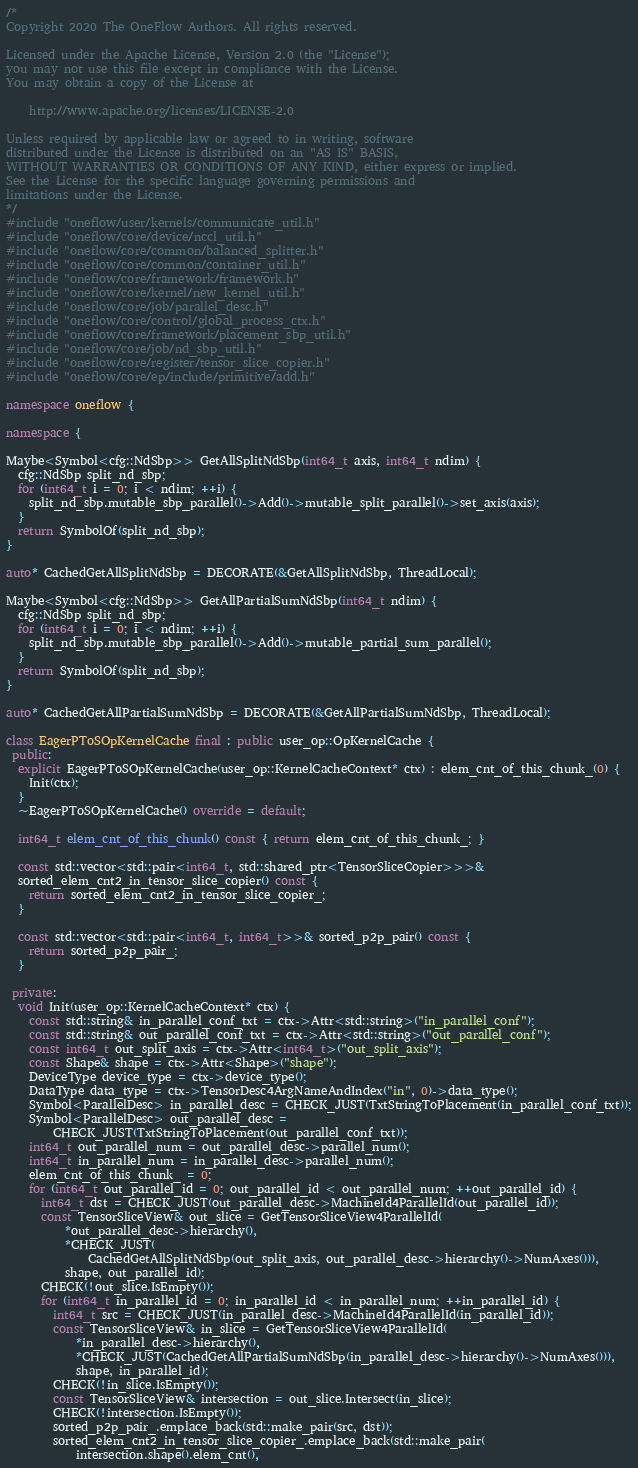<code> <loc_0><loc_0><loc_500><loc_500><_C++_>/*
Copyright 2020 The OneFlow Authors. All rights reserved.

Licensed under the Apache License, Version 2.0 (the "License");
you may not use this file except in compliance with the License.
You may obtain a copy of the License at

    http://www.apache.org/licenses/LICENSE-2.0

Unless required by applicable law or agreed to in writing, software
distributed under the License is distributed on an "AS IS" BASIS,
WITHOUT WARRANTIES OR CONDITIONS OF ANY KIND, either express or implied.
See the License for the specific language governing permissions and
limitations under the License.
*/
#include "oneflow/user/kernels/communicate_util.h"
#include "oneflow/core/device/nccl_util.h"
#include "oneflow/core/common/balanced_splitter.h"
#include "oneflow/core/common/container_util.h"
#include "oneflow/core/framework/framework.h"
#include "oneflow/core/kernel/new_kernel_util.h"
#include "oneflow/core/job/parallel_desc.h"
#include "oneflow/core/control/global_process_ctx.h"
#include "oneflow/core/framework/placement_sbp_util.h"
#include "oneflow/core/job/nd_sbp_util.h"
#include "oneflow/core/register/tensor_slice_copier.h"
#include "oneflow/core/ep/include/primitive/add.h"

namespace oneflow {

namespace {

Maybe<Symbol<cfg::NdSbp>> GetAllSplitNdSbp(int64_t axis, int64_t ndim) {
  cfg::NdSbp split_nd_sbp;
  for (int64_t i = 0; i < ndim; ++i) {
    split_nd_sbp.mutable_sbp_parallel()->Add()->mutable_split_parallel()->set_axis(axis);
  }
  return SymbolOf(split_nd_sbp);
}

auto* CachedGetAllSplitNdSbp = DECORATE(&GetAllSplitNdSbp, ThreadLocal);

Maybe<Symbol<cfg::NdSbp>> GetAllPartialSumNdSbp(int64_t ndim) {
  cfg::NdSbp split_nd_sbp;
  for (int64_t i = 0; i < ndim; ++i) {
    split_nd_sbp.mutable_sbp_parallel()->Add()->mutable_partial_sum_parallel();
  }
  return SymbolOf(split_nd_sbp);
}

auto* CachedGetAllPartialSumNdSbp = DECORATE(&GetAllPartialSumNdSbp, ThreadLocal);

class EagerPToSOpKernelCache final : public user_op::OpKernelCache {
 public:
  explicit EagerPToSOpKernelCache(user_op::KernelCacheContext* ctx) : elem_cnt_of_this_chunk_(0) {
    Init(ctx);
  }
  ~EagerPToSOpKernelCache() override = default;

  int64_t elem_cnt_of_this_chunk() const { return elem_cnt_of_this_chunk_; }

  const std::vector<std::pair<int64_t, std::shared_ptr<TensorSliceCopier>>>&
  sorted_elem_cnt2_in_tensor_slice_copier() const {
    return sorted_elem_cnt2_in_tensor_slice_copier_;
  }

  const std::vector<std::pair<int64_t, int64_t>>& sorted_p2p_pair() const {
    return sorted_p2p_pair_;
  }

 private:
  void Init(user_op::KernelCacheContext* ctx) {
    const std::string& in_parallel_conf_txt = ctx->Attr<std::string>("in_parallel_conf");
    const std::string& out_parallel_conf_txt = ctx->Attr<std::string>("out_parallel_conf");
    const int64_t out_split_axis = ctx->Attr<int64_t>("out_split_axis");
    const Shape& shape = ctx->Attr<Shape>("shape");
    DeviceType device_type = ctx->device_type();
    DataType data_type = ctx->TensorDesc4ArgNameAndIndex("in", 0)->data_type();
    Symbol<ParallelDesc> in_parallel_desc = CHECK_JUST(TxtStringToPlacement(in_parallel_conf_txt));
    Symbol<ParallelDesc> out_parallel_desc =
        CHECK_JUST(TxtStringToPlacement(out_parallel_conf_txt));
    int64_t out_parallel_num = out_parallel_desc->parallel_num();
    int64_t in_parallel_num = in_parallel_desc->parallel_num();
    elem_cnt_of_this_chunk_ = 0;
    for (int64_t out_parallel_id = 0; out_parallel_id < out_parallel_num; ++out_parallel_id) {
      int64_t dst = CHECK_JUST(out_parallel_desc->MachineId4ParallelId(out_parallel_id));
      const TensorSliceView& out_slice = GetTensorSliceView4ParallelId(
          *out_parallel_desc->hierarchy(),
          *CHECK_JUST(
              CachedGetAllSplitNdSbp(out_split_axis, out_parallel_desc->hierarchy()->NumAxes())),
          shape, out_parallel_id);
      CHECK(!out_slice.IsEmpty());
      for (int64_t in_parallel_id = 0; in_parallel_id < in_parallel_num; ++in_parallel_id) {
        int64_t src = CHECK_JUST(in_parallel_desc->MachineId4ParallelId(in_parallel_id));
        const TensorSliceView& in_slice = GetTensorSliceView4ParallelId(
            *in_parallel_desc->hierarchy(),
            *CHECK_JUST(CachedGetAllPartialSumNdSbp(in_parallel_desc->hierarchy()->NumAxes())),
            shape, in_parallel_id);
        CHECK(!in_slice.IsEmpty());
        const TensorSliceView& intersection = out_slice.Intersect(in_slice);
        CHECK(!intersection.IsEmpty());
        sorted_p2p_pair_.emplace_back(std::make_pair(src, dst));
        sorted_elem_cnt2_in_tensor_slice_copier_.emplace_back(std::make_pair(
            intersection.shape().elem_cnt(),</code> 